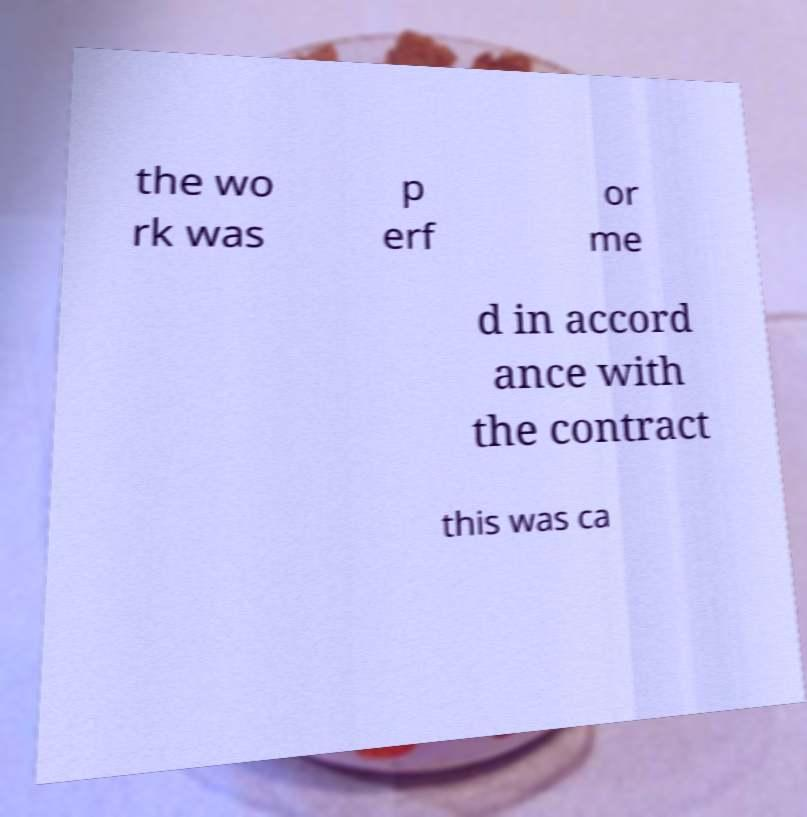Please read and relay the text visible in this image. What does it say? the wo rk was p erf or me d in accord ance with the contract this was ca 